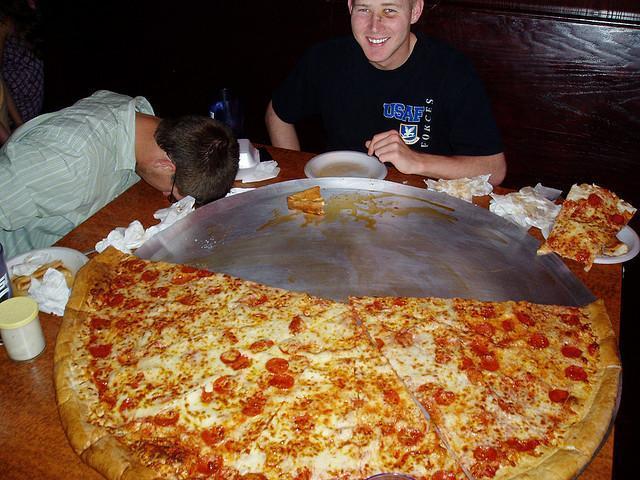How many pizzas are in the photo?
Give a very brief answer. 2. How many people are in the photo?
Give a very brief answer. 2. How many red frisbees are airborne?
Give a very brief answer. 0. 